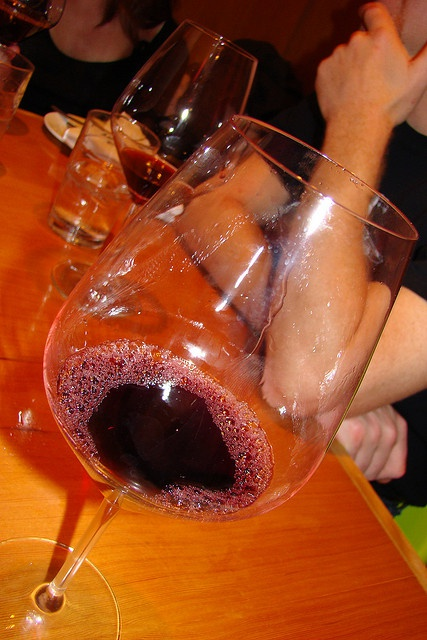Describe the objects in this image and their specific colors. I can see wine glass in maroon, brown, black, and red tones, people in maroon and black tones, wine glass in maroon, black, and brown tones, cup in maroon, brown, and red tones, and wine glass in maroon and black tones in this image. 